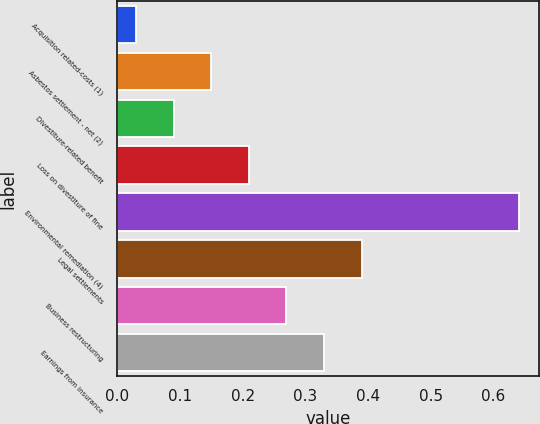<chart> <loc_0><loc_0><loc_500><loc_500><bar_chart><fcel>Acquisition related-costs (1)<fcel>Asbestos settlement - net (2)<fcel>Divestiture-related benefit<fcel>Loss on divestiture of fine<fcel>Environmental remediation (4)<fcel>Legal settlements<fcel>Business restructuring<fcel>Earnings from insurance<nl><fcel>0.03<fcel>0.15<fcel>0.09<fcel>0.21<fcel>0.64<fcel>0.39<fcel>0.27<fcel>0.33<nl></chart> 